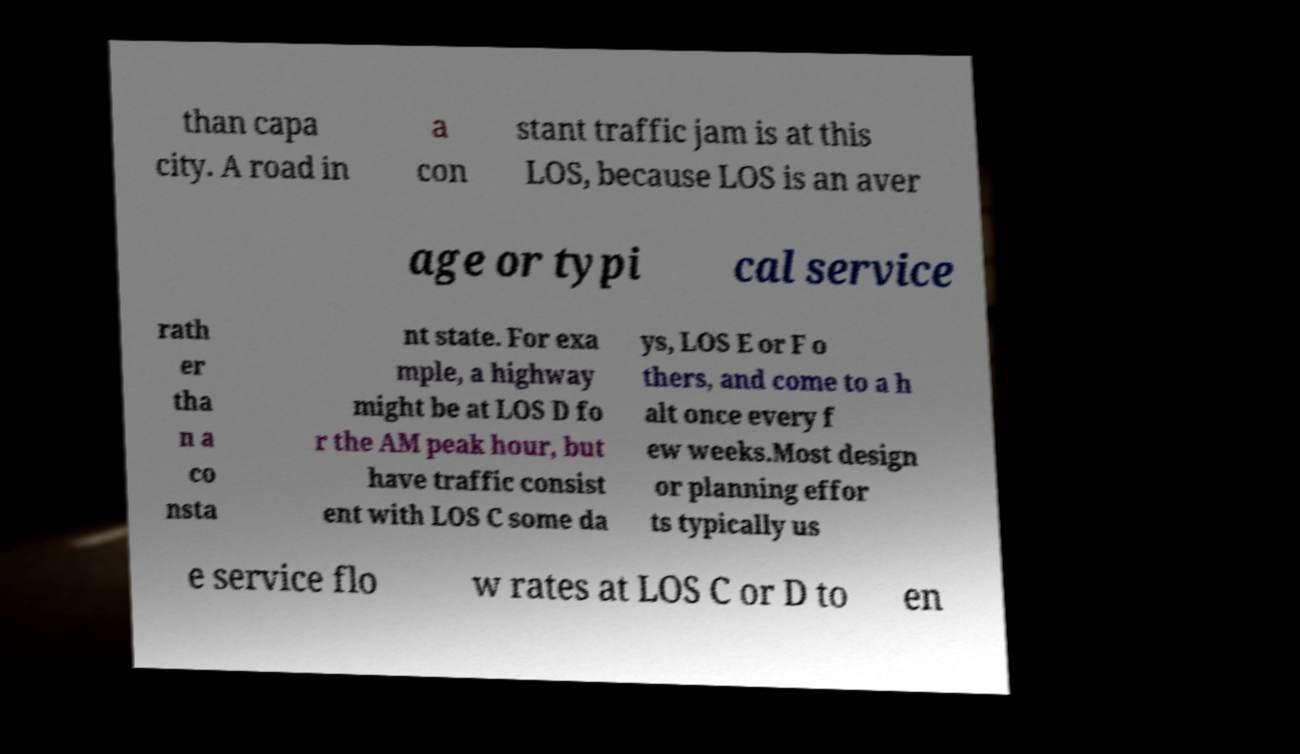Please read and relay the text visible in this image. What does it say? than capa city. A road in a con stant traffic jam is at this LOS, because LOS is an aver age or typi cal service rath er tha n a co nsta nt state. For exa mple, a highway might be at LOS D fo r the AM peak hour, but have traffic consist ent with LOS C some da ys, LOS E or F o thers, and come to a h alt once every f ew weeks.Most design or planning effor ts typically us e service flo w rates at LOS C or D to en 